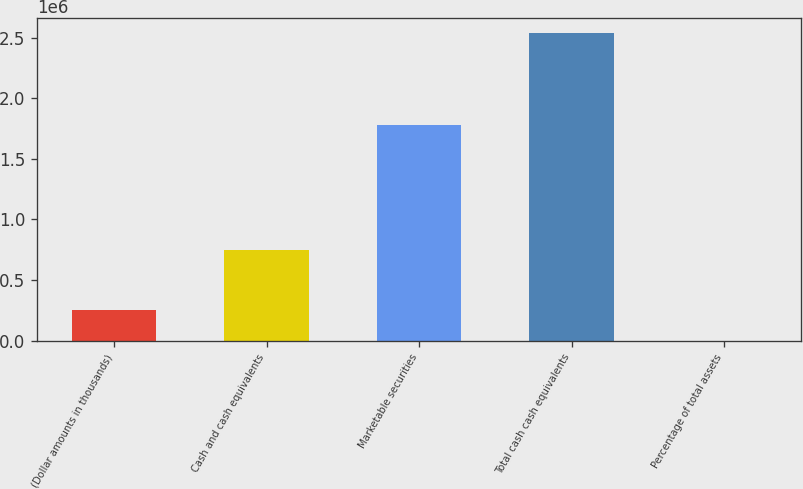Convert chart to OTSL. <chart><loc_0><loc_0><loc_500><loc_500><bar_chart><fcel>(Dollar amounts in thousands)<fcel>Cash and cash equivalents<fcel>Marketable securities<fcel>Total cash cash equivalents<fcel>Percentage of total assets<nl><fcel>253489<fcel>751294<fcel>1.78315e+06<fcel>2.53444e+06<fcel>50<nl></chart> 